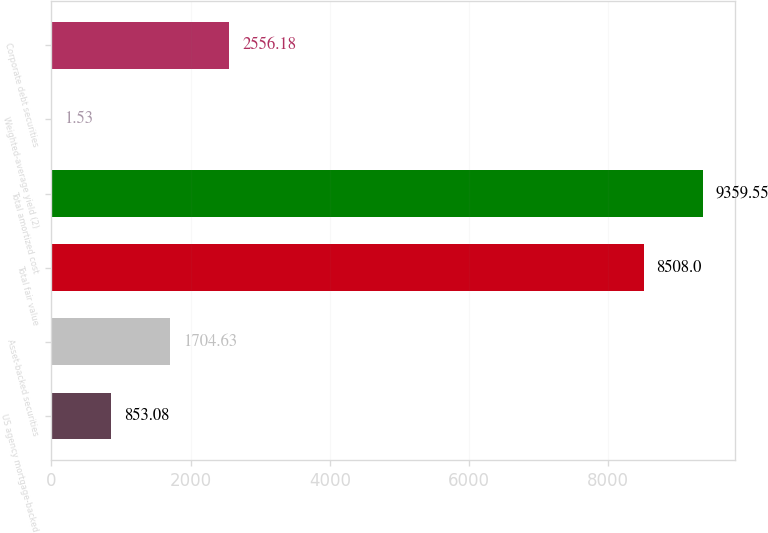<chart> <loc_0><loc_0><loc_500><loc_500><bar_chart><fcel>US agency mortgage-backed<fcel>Asset-backed securities<fcel>Total fair value<fcel>Total amortized cost<fcel>Weighted-average yield (2)<fcel>Corporate debt securities<nl><fcel>853.08<fcel>1704.63<fcel>8508<fcel>9359.55<fcel>1.53<fcel>2556.18<nl></chart> 